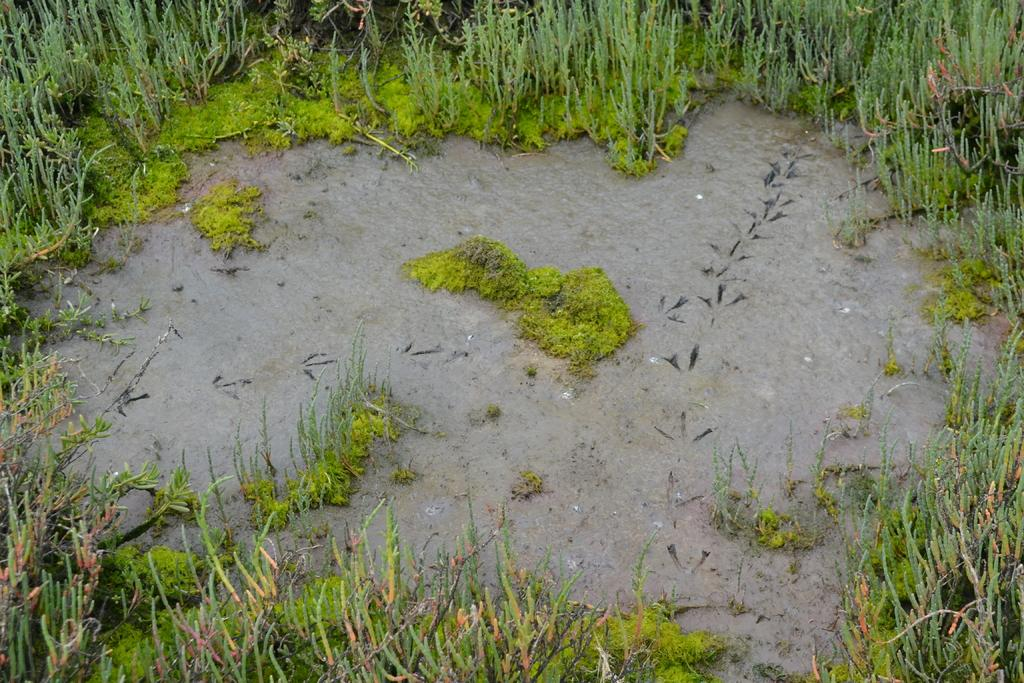What is covering the ground in the image? There is water on the ground in the image. What type of vegetation can be seen in the image? There are small plants in the image. What color is the grass in the image? There is green grass on the ground in the image. Where is the banana located in the image? There is no banana present in the image. What type of chain can be seen connecting the plants in the image? There is no chain present in the image; the plants are not connected. 